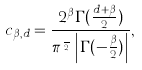Convert formula to latex. <formula><loc_0><loc_0><loc_500><loc_500>c _ { \beta , d } = \frac { 2 ^ { \beta } \Gamma ( \frac { d + \beta } { 2 } ) } { \pi ^ { \frac { d } { 2 } } \left | \Gamma ( - \frac { \beta } { 2 } ) \right | } ,</formula> 